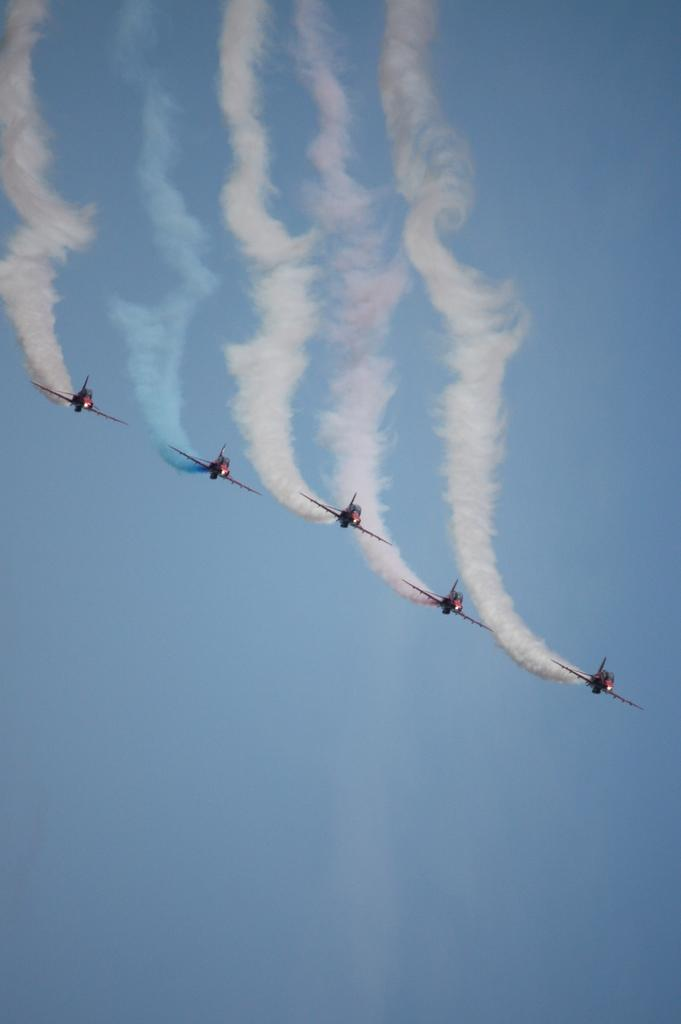How many rockets are in the image? There are five rockets in the image. What are the rockets doing in the image? The rockets are flying in the air. What can be seen coming out of the rockets in the image? There is colorful smoke visible in the image. What is visible in the background of the image? The sky is visible in the image. What type of fowl can be seen flying alongside the rockets in the image? There are no birds or fowl visible in the image; only the rockets and colorful smoke are present. Can you tell me how many apples are on the rockets in the image? There are no apples present in the image; the rockets are the main focus. 